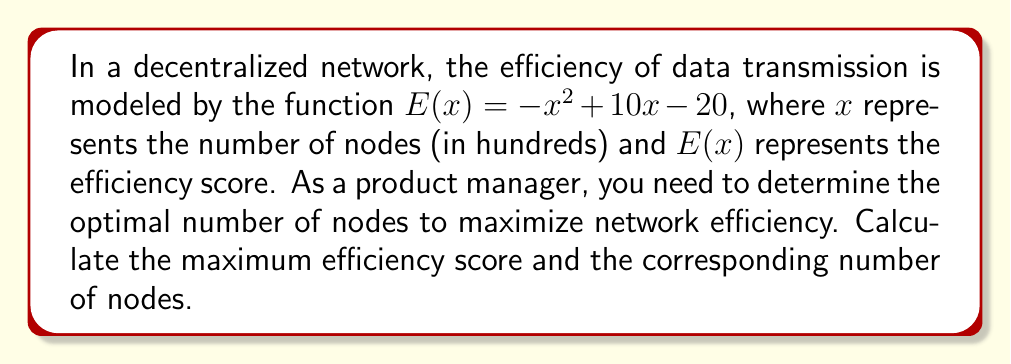Help me with this question. To solve this problem, we'll use calculus to find the maximum of the given function.

1) The efficiency function is given by:
   $$E(x) = -x^2 + 10x - 20$$

2) To find the maximum, we need to find where the derivative of $E(x)$ equals zero:
   $$\frac{dE}{dx} = -2x + 10$$

3) Set the derivative to zero and solve for x:
   $$-2x + 10 = 0$$
   $$-2x = -10$$
   $$x = 5$$

4) To confirm this is a maximum (not a minimum), check the second derivative:
   $$\frac{d^2E}{dx^2} = -2$$
   Since this is negative, we confirm that $x = 5$ gives a maximum.

5) Calculate the maximum efficiency score by plugging $x = 5$ into the original function:
   $$E(5) = -(5)^2 + 10(5) - 20$$
   $$= -25 + 50 - 20$$
   $$= 5$$

6) Interpret the results:
   - The optimal number of nodes is 5 hundred, or 500 nodes.
   - The maximum efficiency score is 5.
Answer: The optimal number of nodes is 500, and the maximum efficiency score is 5. 